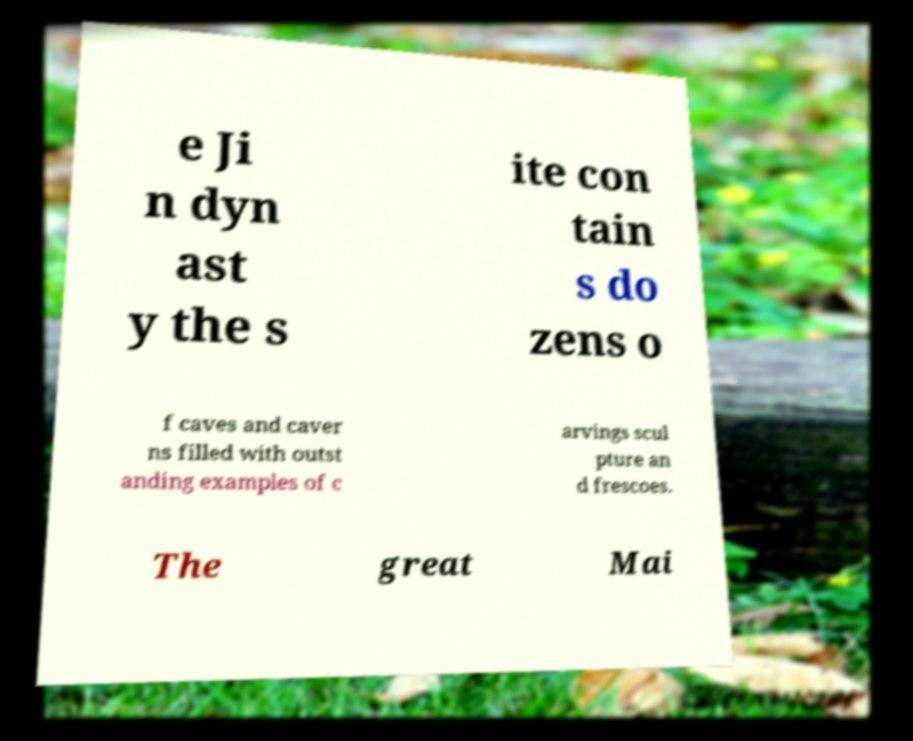Please read and relay the text visible in this image. What does it say? e Ji n dyn ast y the s ite con tain s do zens o f caves and caver ns filled with outst anding examples of c arvings scul pture an d frescoes. The great Mai 